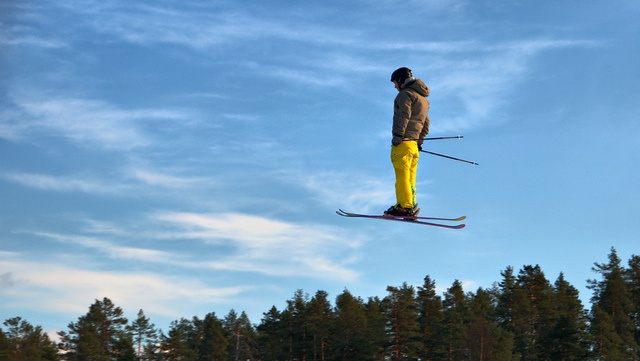Describe the objects in this image and their specific colors. I can see people in gray, black, olive, and gold tones and skis in gray, navy, and purple tones in this image. 